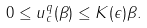<formula> <loc_0><loc_0><loc_500><loc_500>0 \leq u ^ { q } _ { c } ( \beta ) \leq K ( \epsilon ) \beta .</formula> 